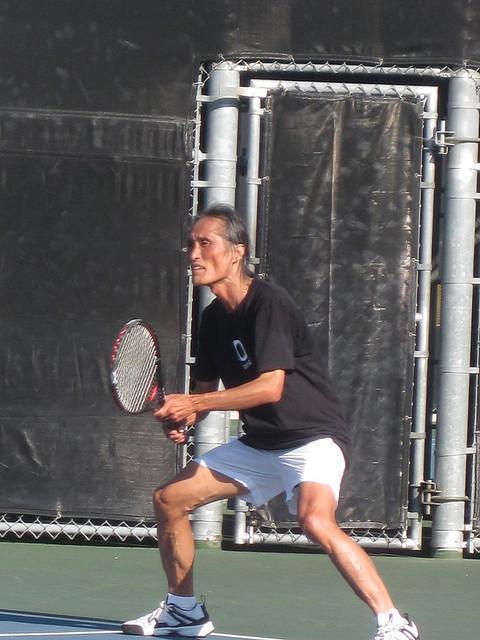How many tennis rackets can you see?
Give a very brief answer. 1. 